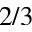Convert formula to latex. <formula><loc_0><loc_0><loc_500><loc_500>2 / 3</formula> 